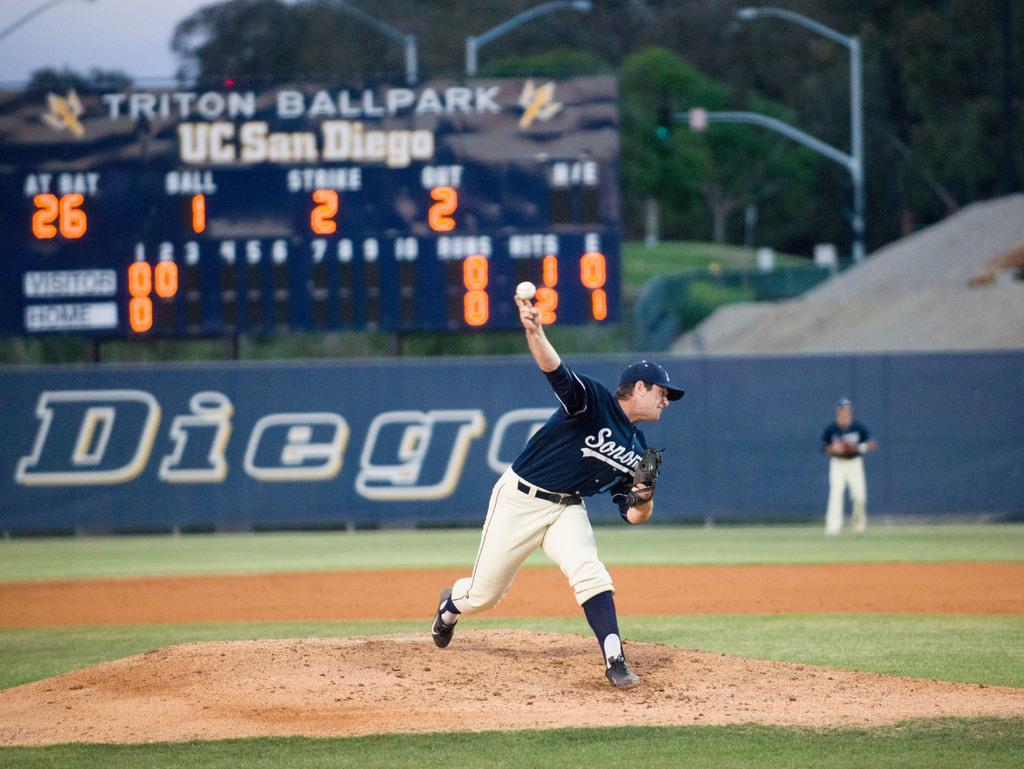<image>
Summarize the visual content of the image. a player throwing a ball with the word Diego on the background wall 